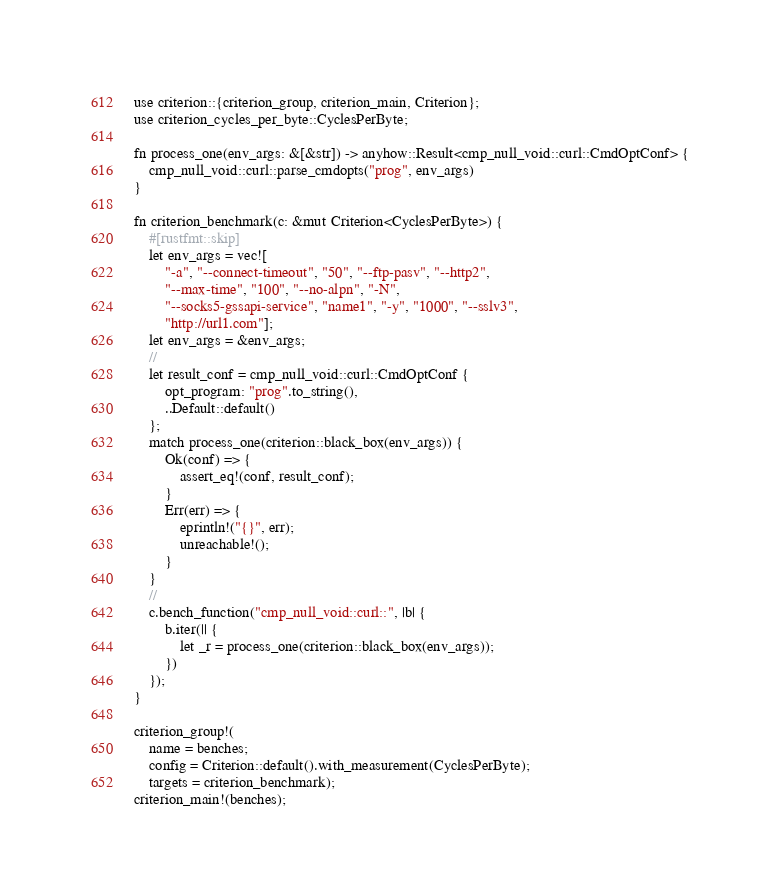Convert code to text. <code><loc_0><loc_0><loc_500><loc_500><_Rust_>use criterion::{criterion_group, criterion_main, Criterion};
use criterion_cycles_per_byte::CyclesPerByte;

fn process_one(env_args: &[&str]) -> anyhow::Result<cmp_null_void::curl::CmdOptConf> {
    cmp_null_void::curl::parse_cmdopts("prog", env_args)
}

fn criterion_benchmark(c: &mut Criterion<CyclesPerByte>) {
    #[rustfmt::skip]
    let env_args = vec![
        "-a", "--connect-timeout", "50", "--ftp-pasv", "--http2",
        "--max-time", "100", "--no-alpn", "-N",
        "--socks5-gssapi-service", "name1", "-y", "1000", "--sslv3",
        "http://url1.com"];
    let env_args = &env_args;
    //
    let result_conf = cmp_null_void::curl::CmdOptConf {
        opt_program: "prog".to_string(),
        ..Default::default()
    };
    match process_one(criterion::black_box(env_args)) {
        Ok(conf) => {
            assert_eq!(conf, result_conf);
        }
        Err(err) => {
            eprintln!("{}", err);
            unreachable!();
        }
    }
    //
    c.bench_function("cmp_null_void::curl::", |b| {
        b.iter(|| {
            let _r = process_one(criterion::black_box(env_args));
        })
    });
}

criterion_group!(
    name = benches;
    config = Criterion::default().with_measurement(CyclesPerByte);
    targets = criterion_benchmark);
criterion_main!(benches);
</code> 